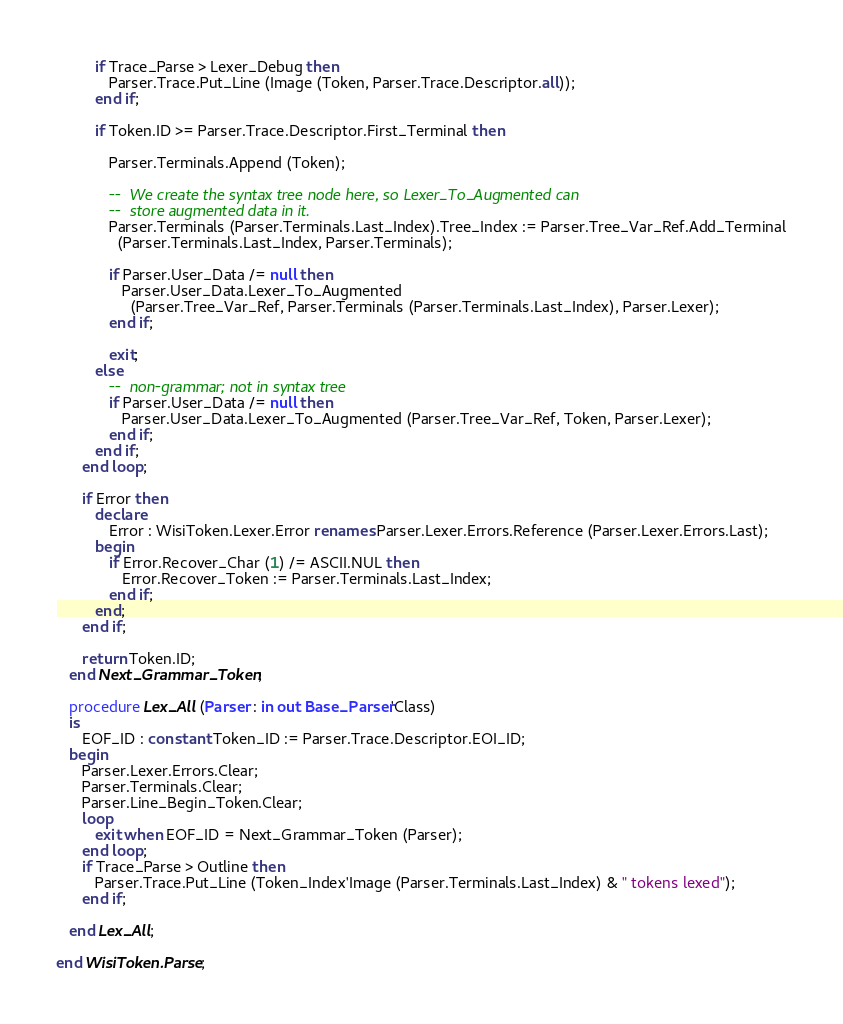Convert code to text. <code><loc_0><loc_0><loc_500><loc_500><_Ada_>         if Trace_Parse > Lexer_Debug then
            Parser.Trace.Put_Line (Image (Token, Parser.Trace.Descriptor.all));
         end if;

         if Token.ID >= Parser.Trace.Descriptor.First_Terminal then

            Parser.Terminals.Append (Token);

            --  We create the syntax tree node here, so Lexer_To_Augmented can
            --  store augmented data in it.
            Parser.Terminals (Parser.Terminals.Last_Index).Tree_Index := Parser.Tree_Var_Ref.Add_Terminal
              (Parser.Terminals.Last_Index, Parser.Terminals);

            if Parser.User_Data /= null then
               Parser.User_Data.Lexer_To_Augmented
                 (Parser.Tree_Var_Ref, Parser.Terminals (Parser.Terminals.Last_Index), Parser.Lexer);
            end if;

            exit;
         else
            --  non-grammar; not in syntax tree
            if Parser.User_Data /= null then
               Parser.User_Data.Lexer_To_Augmented (Parser.Tree_Var_Ref, Token, Parser.Lexer);
            end if;
         end if;
      end loop;

      if Error then
         declare
            Error : WisiToken.Lexer.Error renames Parser.Lexer.Errors.Reference (Parser.Lexer.Errors.Last);
         begin
            if Error.Recover_Char (1) /= ASCII.NUL then
               Error.Recover_Token := Parser.Terminals.Last_Index;
            end if;
         end;
      end if;

      return Token.ID;
   end Next_Grammar_Token;

   procedure Lex_All (Parser : in out Base_Parser'Class)
   is
      EOF_ID : constant Token_ID := Parser.Trace.Descriptor.EOI_ID;
   begin
      Parser.Lexer.Errors.Clear;
      Parser.Terminals.Clear;
      Parser.Line_Begin_Token.Clear;
      loop
         exit when EOF_ID = Next_Grammar_Token (Parser);
      end loop;
      if Trace_Parse > Outline then
         Parser.Trace.Put_Line (Token_Index'Image (Parser.Terminals.Last_Index) & " tokens lexed");
      end if;

   end Lex_All;

end WisiToken.Parse;
</code> 